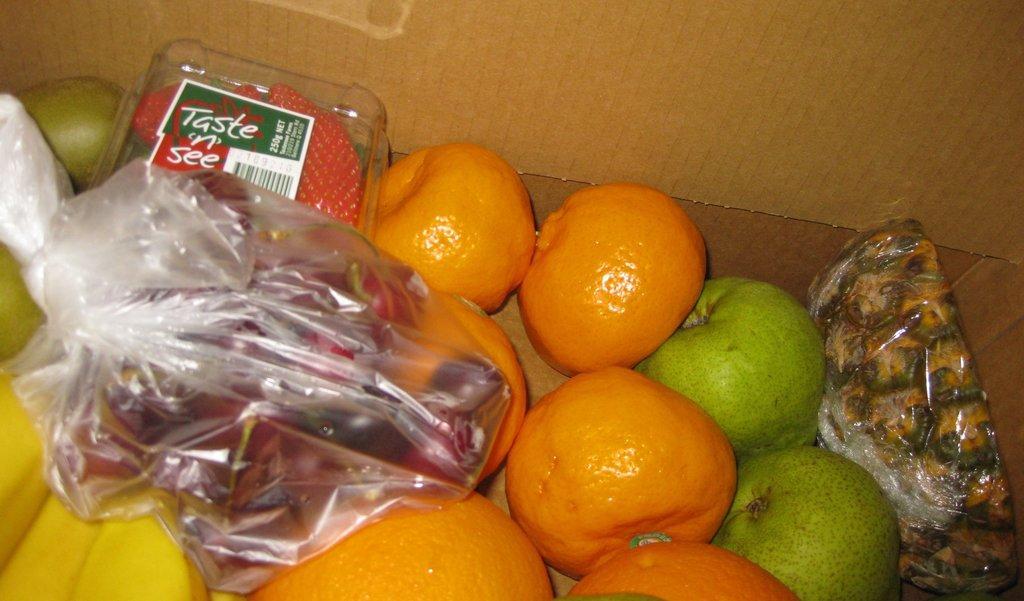How would you summarize this image in a sentence or two? In this picture, we see a carton box in which oranges, guavas, bananas, pears, dates, a plastic cover containing grapes and a box containing strawberries are placed. 